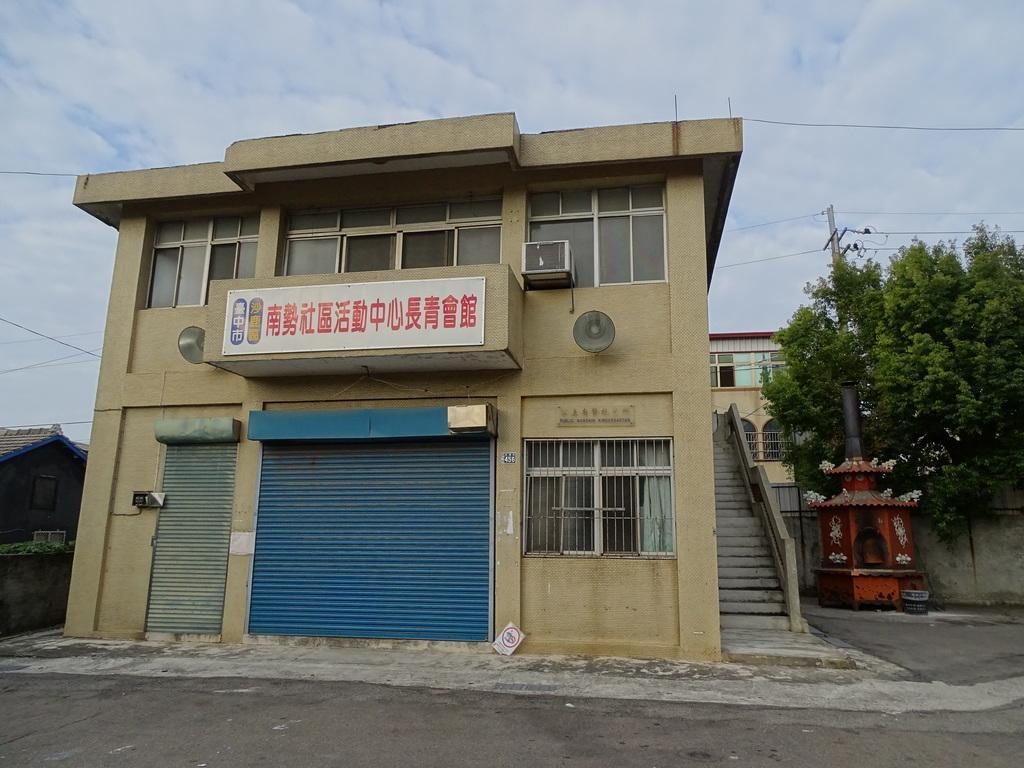Can you describe this image briefly? In this image in the front there is a building and on the building there is some text written on it and on the right side of the building there are trees, there is a pole and there is a staircase and there is a building and there is an object which is red in colour. On the left side of the building there is a building and the sky is cloudy. 